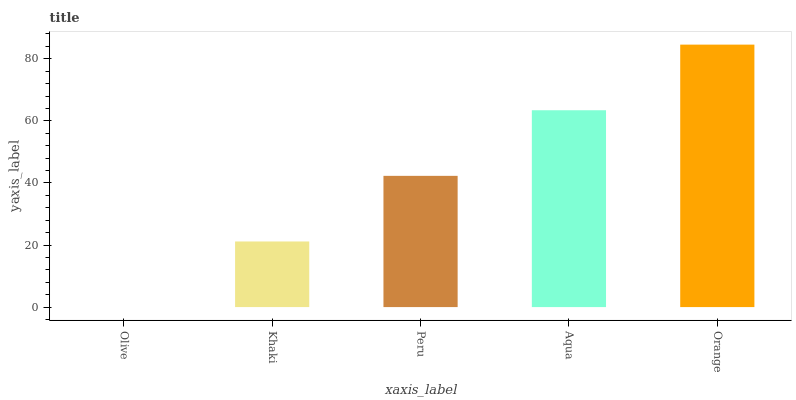Is Olive the minimum?
Answer yes or no. Yes. Is Orange the maximum?
Answer yes or no. Yes. Is Khaki the minimum?
Answer yes or no. No. Is Khaki the maximum?
Answer yes or no. No. Is Khaki greater than Olive?
Answer yes or no. Yes. Is Olive less than Khaki?
Answer yes or no. Yes. Is Olive greater than Khaki?
Answer yes or no. No. Is Khaki less than Olive?
Answer yes or no. No. Is Peru the high median?
Answer yes or no. Yes. Is Peru the low median?
Answer yes or no. Yes. Is Orange the high median?
Answer yes or no. No. Is Olive the low median?
Answer yes or no. No. 